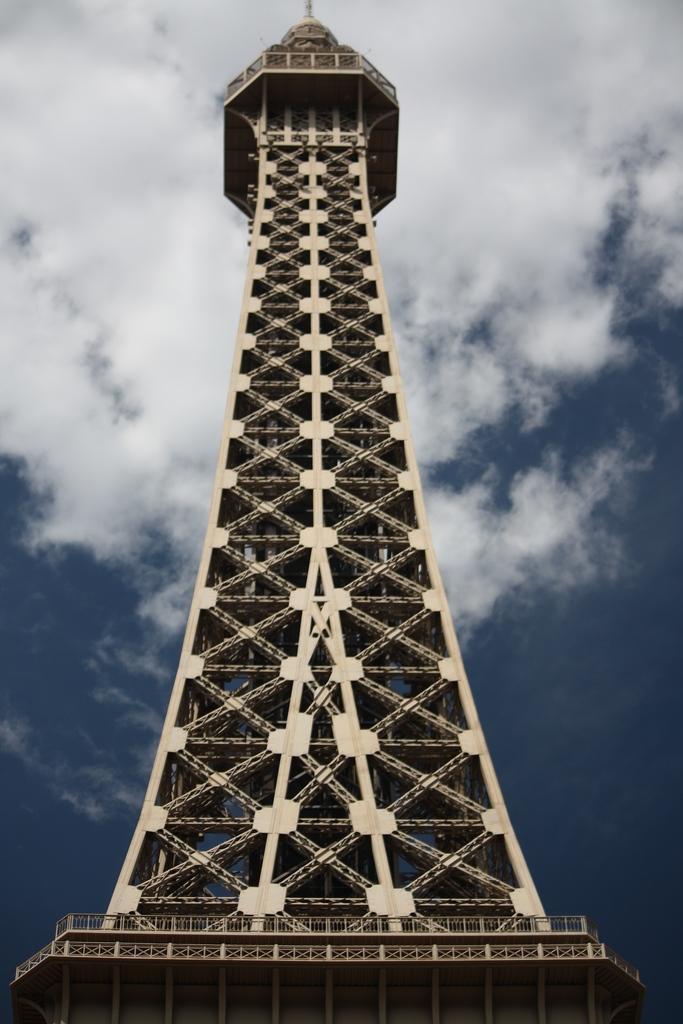In one or two sentences, can you explain what this image depicts? In this image I can see the Eiffel Tower in the front. In the background I can see clouds and the sky. 